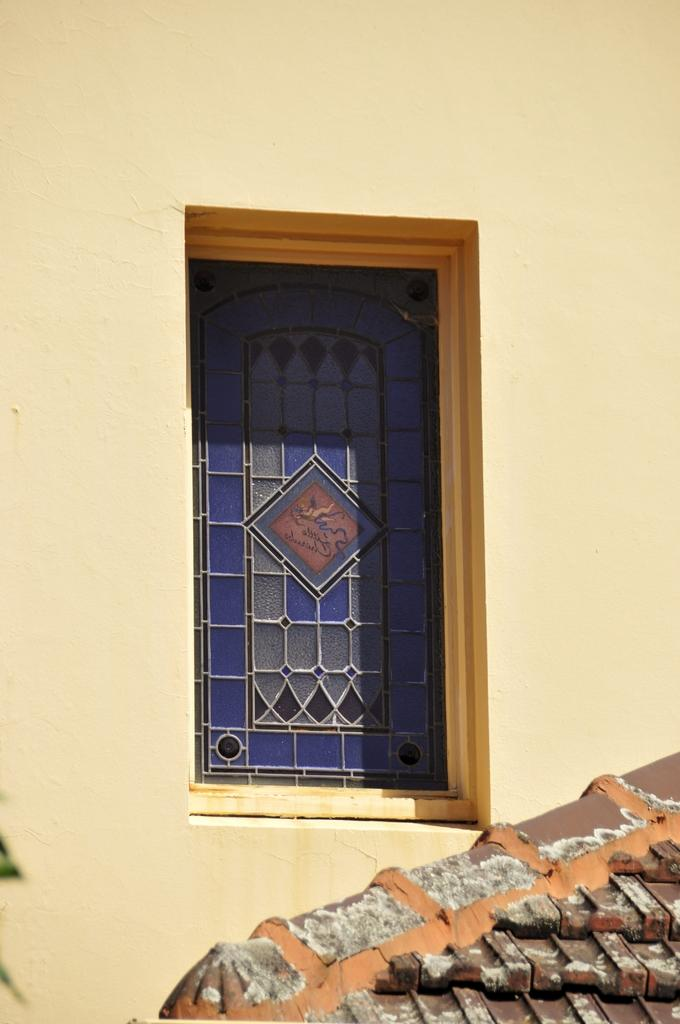What type of structure can be seen in the image? There is a wall, a window, and a roof of a house in the image. Can you describe the window in the image? The image shows a window, which is a common feature in buildings. What is the primary purpose of the wall in the image? The wall in the image is likely part of a building, providing support and structure. What type of watch can be seen on the wall in the image? There is no watch present on the wall in the image. What color is the vest hanging on the wall in the image? There is no vest present on the wall in the image. 